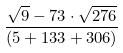<formula> <loc_0><loc_0><loc_500><loc_500>\frac { \sqrt { 9 } - 7 3 \cdot \sqrt { 2 7 6 } } { ( 5 + 1 3 3 + 3 0 6 ) }</formula> 